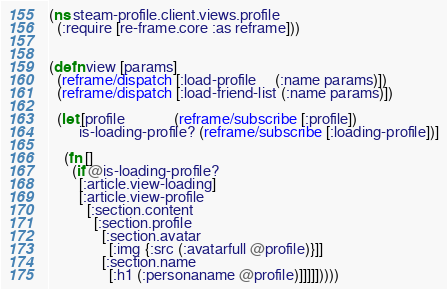Convert code to text. <code><loc_0><loc_0><loc_500><loc_500><_Clojure_>(ns steam-profile.client.views.profile
  (:require [re-frame.core :as reframe]))


(defn view [params]
  (reframe/dispatch [:load-profile     (:name params)])
  (reframe/dispatch [:load-friend-list (:name params)])

  (let [profile             (reframe/subscribe [:profile])
        is-loading-profile? (reframe/subscribe [:loading-profile])]

    (fn []
      (if @is-loading-profile?
        [:article.view-loading]
        [:article.view-profile
          [:section.content
            [:section.profile
              [:section.avatar
                [:img {:src (:avatarfull @profile)}]]
              [:section.name
                [:h1 (:personaname @profile)]]]]]))))
</code> 